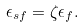Convert formula to latex. <formula><loc_0><loc_0><loc_500><loc_500>\epsilon _ { s f } = \zeta \epsilon _ { f } .</formula> 